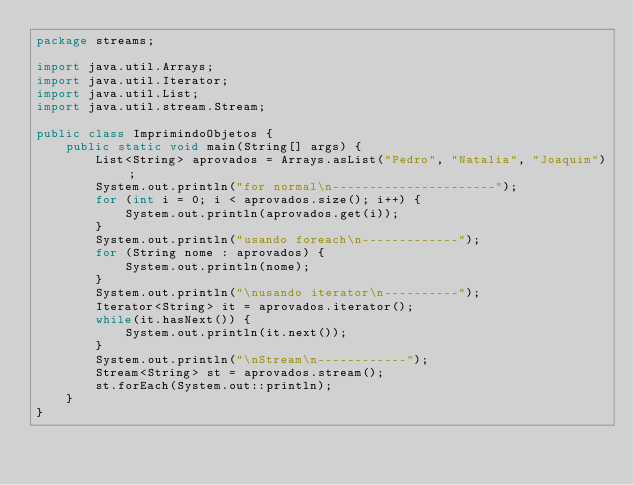<code> <loc_0><loc_0><loc_500><loc_500><_Java_>package streams;

import java.util.Arrays;
import java.util.Iterator;
import java.util.List;
import java.util.stream.Stream;

public class ImprimindoObjetos {
	public static void main(String[] args) {
		List<String> aprovados = Arrays.asList("Pedro", "Natalia", "Joaquim");
		System.out.println("for normal\n----------------------");
		for (int i = 0; i < aprovados.size(); i++) {
			System.out.println(aprovados.get(i));
		}
		System.out.println("usando foreach\n-------------");
		for (String nome : aprovados) {
			System.out.println(nome);
		}
		System.out.println("\nusando iterator\n----------");
		Iterator<String> it = aprovados.iterator();
		while(it.hasNext()) {
			System.out.println(it.next());
		}
		System.out.println("\nStream\n------------");
		Stream<String> st = aprovados.stream();
		st.forEach(System.out::println);
	}
}
</code> 